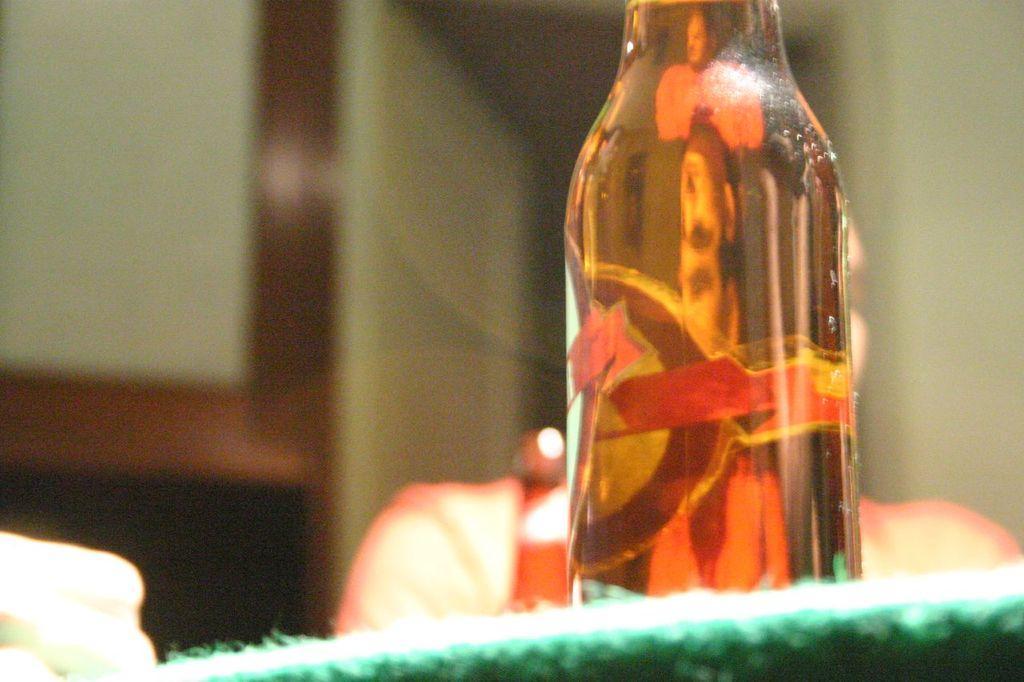Can you describe this image briefly? This picture shows a bottle on the table 